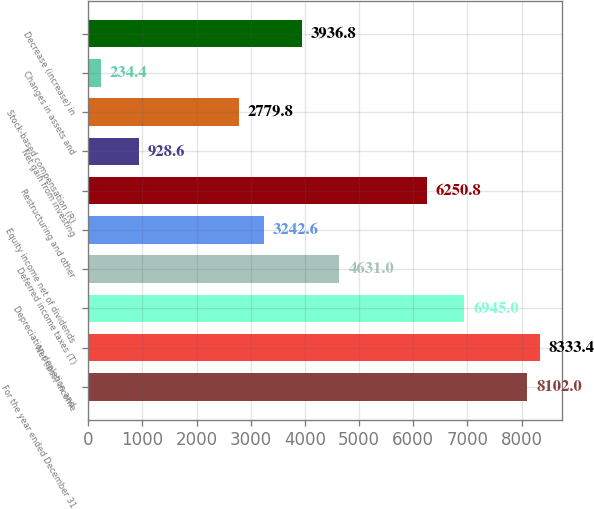Convert chart to OTSL. <chart><loc_0><loc_0><loc_500><loc_500><bar_chart><fcel>For the year ended December 31<fcel>Net (loss) income<fcel>Depreciation depletion and<fcel>Deferred income taxes (T)<fcel>Equity income net of dividends<fcel>Restructuring and other<fcel>Net gain from investing<fcel>Stock-based compensation (R)<fcel>Changes in assets and<fcel>Decrease (increase) in<nl><fcel>8102<fcel>8333.4<fcel>6945<fcel>4631<fcel>3242.6<fcel>6250.8<fcel>928.6<fcel>2779.8<fcel>234.4<fcel>3936.8<nl></chart> 